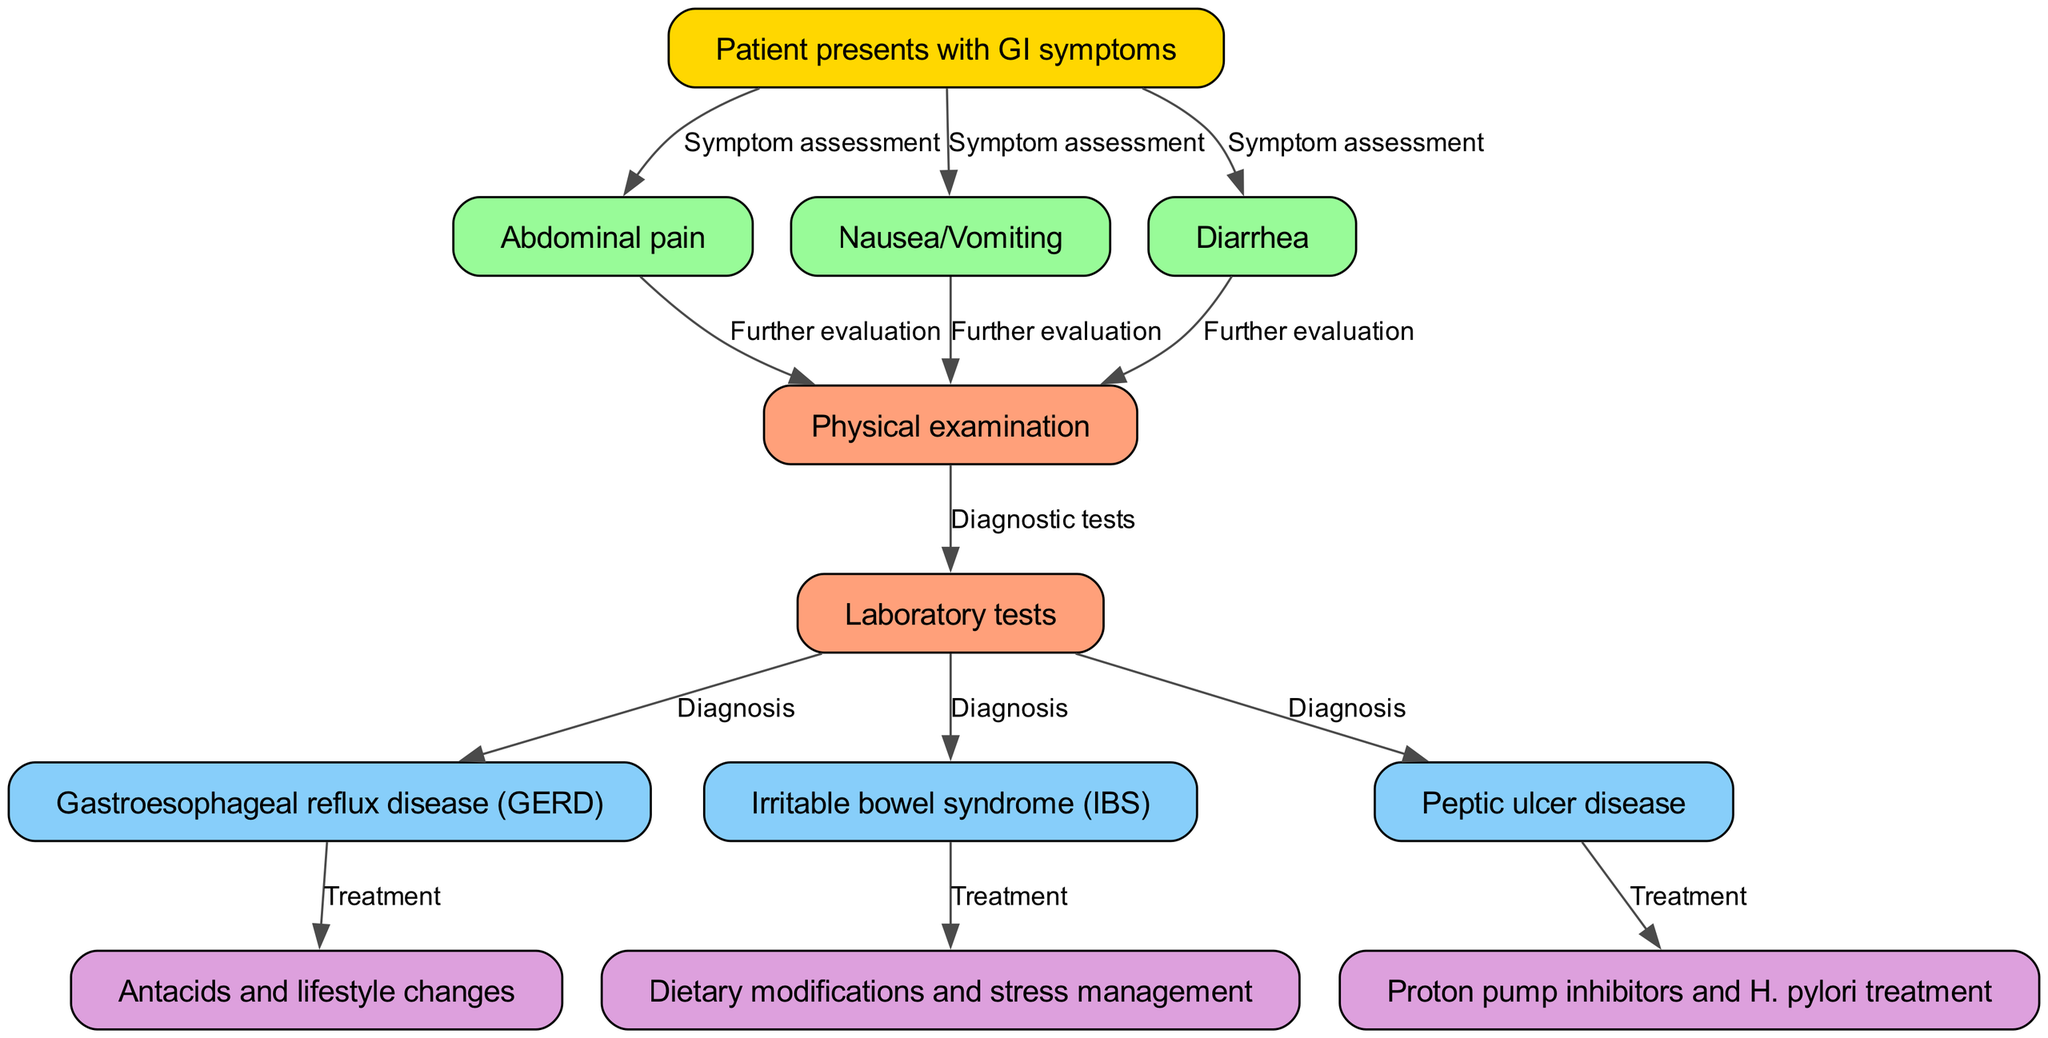What is the first node in the diagram? The first node, which represents the initial step in the diagnostic process, is identified as "Patient presents with GI symptoms." This node serves as the starting point for all subsequent evaluations and treatments.
Answer: Patient presents with GI symptoms How many treatment options are listed in the diagram? By examining the nodes categorized as treatment options, we can see three specific treatments: "Antacids and lifestyle changes," "Dietary modifications and stress management," and "Proton pump inhibitors and H. pylori treatment." Counting these options gives us a total of three distinct treatments.
Answer: 3 Which node follows "Physical examination"? Following the "Physical examination" node in the flowchart is the "Laboratory tests" node. This shows the progression from physical evaluation to the necessity of conducting further diagnostic tests.
Answer: Laboratory tests What symptom is related to "Gastroesophageal reflux disease (GERD)"? The symptom that leads to the diagnosis of "Gastroesophageal reflux disease (GERD)" is "Abdominal pain." This relationship indicates that if a patient presents with abdominal pain, further steps may lead to diagnosing GERD specifically.
Answer: Abdominal pain Describe the relationship between "Laboratory tests" and "Irritable bowel syndrome (IBS)." In the diagram, the "Laboratory tests" node connects to the "Irritable bowel syndrome (IBS)" node with an edge labeled "Diagnosis." This indicates that the results from laboratory tests can lead healthcare providers to diagnose a patient with IBS based on those findings.
Answer: Diagnosis Which node indicates treatment for "Peptic ulcer disease"? The node that indicates treatment for "Peptic ulcer disease" is "Proton pump inhibitors and H. pylori treatment." This connects directly to the diagnosis, showing the next steps in managing this condition.
Answer: Proton pump inhibitors and H. pylori treatment What type of diagnostic action follows each symptom assessment in the flowchart? Each symptom assessment, whether it’s for abdominal pain, nausea/vomiting, or diarrhea, is followed by the same diagnostic action: "Further evaluation." This means that no matter which symptom is present, further evaluation is the next necessary step.
Answer: Further evaluation Which two diagnoses stem from the "Laboratory tests"? From the "Laboratory tests" node, the two diagnoses that stem from it are "Gastroesophageal reflux disease (GERD)" and "Irritable bowel syndrome (IBS)." This indicates that laboratory tests can lead to multiple potential diagnoses.
Answer: Gastroesophageal reflux disease (GERD) and Irritable bowel syndrome (IBS) 